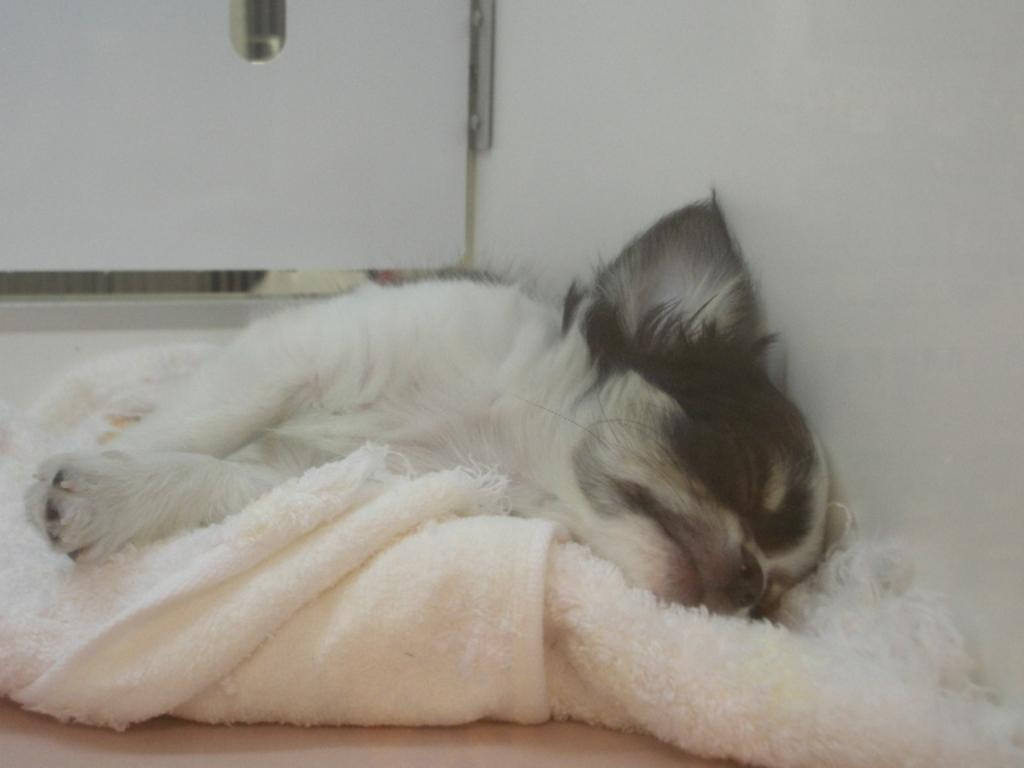What type of animal can be seen in the image? There is an animal in the image, but the specific type is not mentioned in the facts. What is the animal doing in the image? The animal is sleeping on a cloth. What is visible on the right side of the image? There is a wall on the right side of the image. What position does the servant hold in the image? There is no servant present in the image. What type of coat is the animal wearing in the image? The animal is not wearing a coat in the image. 